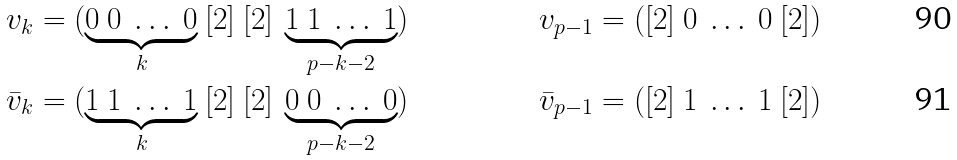<formula> <loc_0><loc_0><loc_500><loc_500>v _ { k } & = ( \underbrace { 0 \ 0 \ \dots \ 0 } _ { k } \ [ 2 ] \ [ 2 ] \ \underbrace { 1 \ 1 \ \dots \ 1 } _ { p - k - 2 } ) & v _ { p - 1 } & = ( [ 2 ] \ 0 \ \dots \ 0 \ [ 2 ] ) \\ \bar { v } _ { k } & = ( \underbrace { 1 \ 1 \ \dots \ 1 } _ { k } \ [ 2 ] \ [ 2 ] \ \underbrace { 0 \ 0 \ \dots \ 0 } _ { p - k - 2 } ) & \bar { v } _ { p - 1 } & = ( [ 2 ] \ 1 \ \dots \ 1 \ [ 2 ] )</formula> 